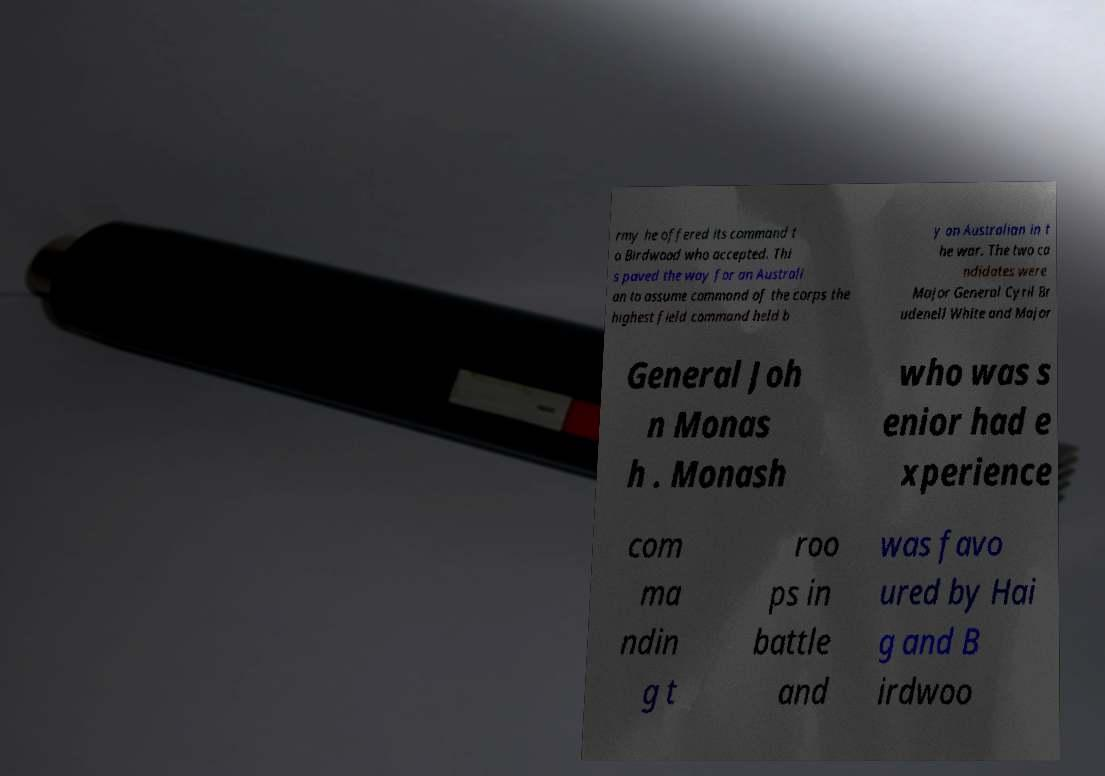Could you extract and type out the text from this image? rmy he offered its command t o Birdwood who accepted. Thi s paved the way for an Australi an to assume command of the corps the highest field command held b y an Australian in t he war. The two ca ndidates were Major General Cyril Br udenell White and Major General Joh n Monas h . Monash who was s enior had e xperience com ma ndin g t roo ps in battle and was favo ured by Hai g and B irdwoo 